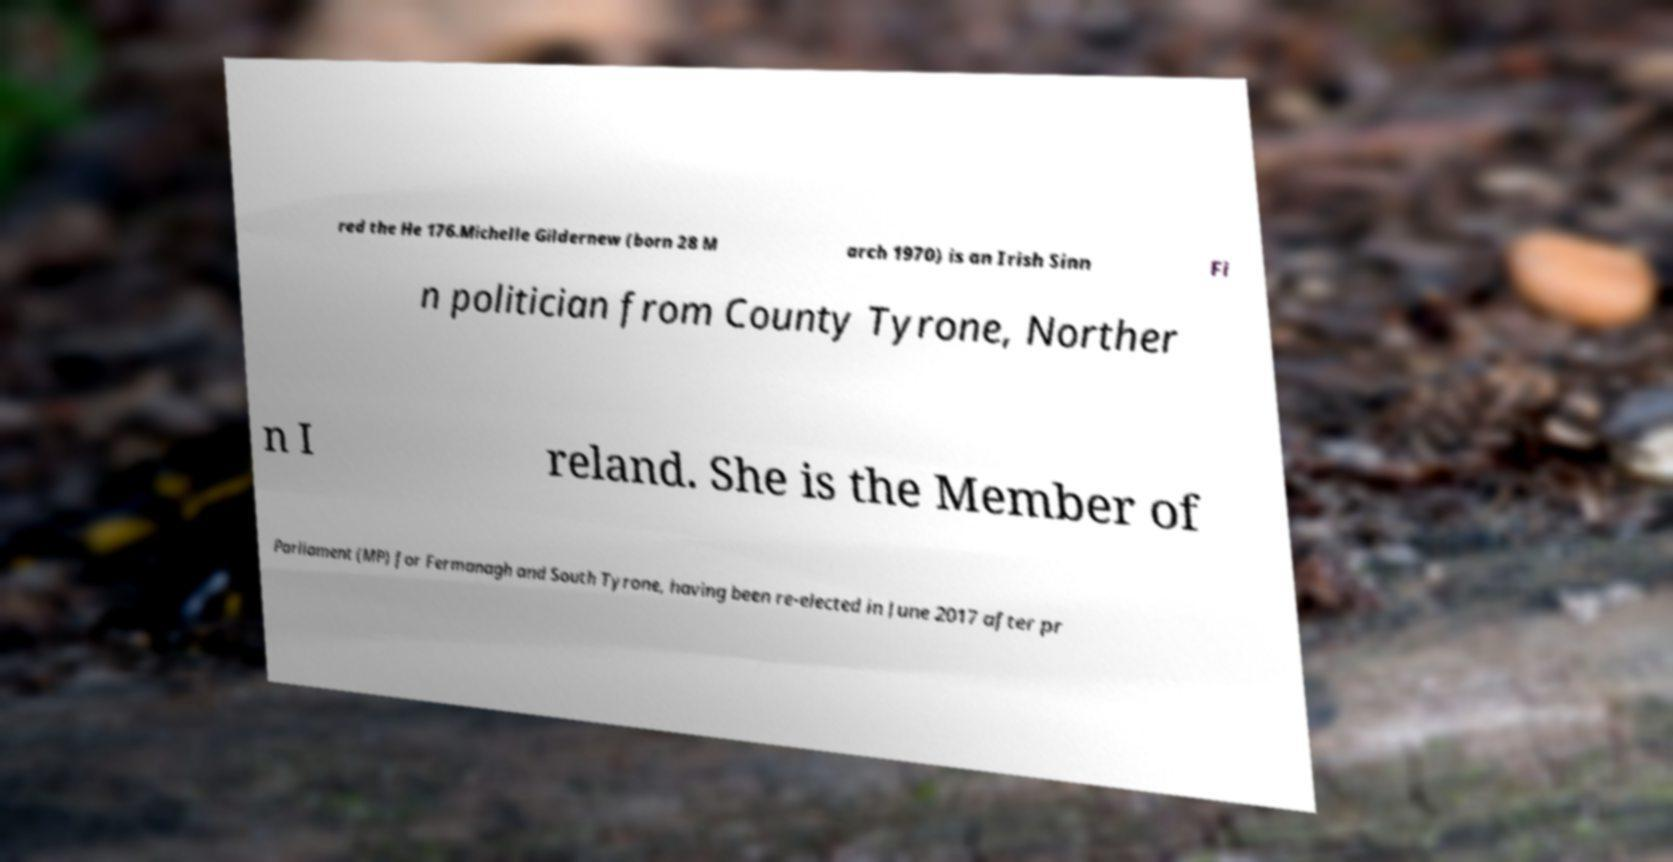Could you assist in decoding the text presented in this image and type it out clearly? red the He 176.Michelle Gildernew (born 28 M arch 1970) is an Irish Sinn Fi n politician from County Tyrone, Norther n I reland. She is the Member of Parliament (MP) for Fermanagh and South Tyrone, having been re-elected in June 2017 after pr 